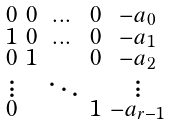Convert formula to latex. <formula><loc_0><loc_0><loc_500><loc_500>\begin{smallmatrix} 0 & 0 & \dots & 0 & - a _ { 0 } \\ 1 & 0 & \dots & 0 & - a _ { 1 } \\ 0 & 1 & & 0 & - a _ { 2 } \\ \vdots & & \ddots & & \vdots \\ 0 & & & 1 & - a _ { r - 1 } \end{smallmatrix}</formula> 